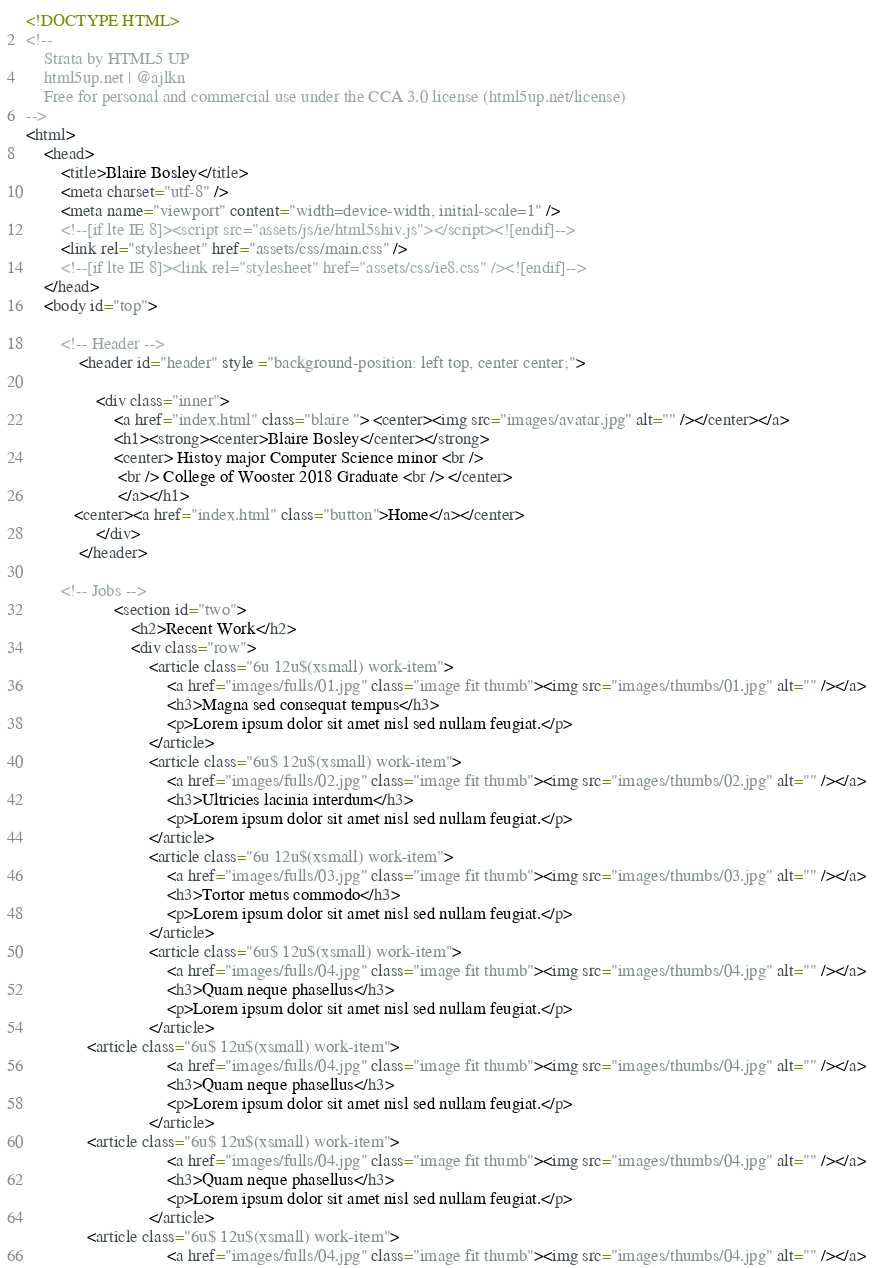<code> <loc_0><loc_0><loc_500><loc_500><_HTML_><!DOCTYPE HTML>
<!--
	Strata by HTML5 UP
	html5up.net | @ajlkn
	Free for personal and commercial use under the CCA 3.0 license (html5up.net/license)
-->
<html>
	<head>
		<title>Blaire Bosley</title>
		<meta charset="utf-8" />
		<meta name="viewport" content="width=device-width, initial-scale=1" />
		<!--[if lte IE 8]><script src="assets/js/ie/html5shiv.js"></script><![endif]-->
		<link rel="stylesheet" href="assets/css/main.css" />
		<!--[if lte IE 8]><link rel="stylesheet" href="assets/css/ie8.css" /><![endif]-->
	</head>
	<body id="top">

		<!-- Header -->
			<header id="header" style ="background-position: left top, center center;">

				<div class="inner">
					<a href="index.html" class="blaire "> <center><img src="images/avatar.jpg" alt="" /></center></a>
					<h1><strong><center>Blaire Bosley</center></strong>
					<center> Histoy major Computer Science minor <br />
					 <br /> College of Wooster 2018 Graduate <br /> </center>
					 </a></h1>
           <center><a href="index.html" class="button">Home</a></center>
				</div>
			</header>

		<!-- Jobs -->
					<section id="two">
						<h2>Recent Work</h2>
						<div class="row">
							<article class="6u 12u$(xsmall) work-item">
								<a href="images/fulls/01.jpg" class="image fit thumb"><img src="images/thumbs/01.jpg" alt="" /></a>
								<h3>Magna sed consequat tempus</h3>
								<p>Lorem ipsum dolor sit amet nisl sed nullam feugiat.</p>
							</article>
							<article class="6u$ 12u$(xsmall) work-item">
								<a href="images/fulls/02.jpg" class="image fit thumb"><img src="images/thumbs/02.jpg" alt="" /></a>
								<h3>Ultricies lacinia interdum</h3>
								<p>Lorem ipsum dolor sit amet nisl sed nullam feugiat.</p>
							</article>
							<article class="6u 12u$(xsmall) work-item">
								<a href="images/fulls/03.jpg" class="image fit thumb"><img src="images/thumbs/03.jpg" alt="" /></a>
								<h3>Tortor metus commodo</h3>
								<p>Lorem ipsum dolor sit amet nisl sed nullam feugiat.</p>
							</article>
							<article class="6u$ 12u$(xsmall) work-item">
								<a href="images/fulls/04.jpg" class="image fit thumb"><img src="images/thumbs/04.jpg" alt="" /></a>
								<h3>Quam neque phasellus</h3>
								<p>Lorem ipsum dolor sit amet nisl sed nullam feugiat.</p>
							</article>
              <article class="6u$ 12u$(xsmall) work-item">
								<a href="images/fulls/04.jpg" class="image fit thumb"><img src="images/thumbs/04.jpg" alt="" /></a>
								<h3>Quam neque phasellus</h3>
								<p>Lorem ipsum dolor sit amet nisl sed nullam feugiat.</p>
							</article>
              <article class="6u$ 12u$(xsmall) work-item">
								<a href="images/fulls/04.jpg" class="image fit thumb"><img src="images/thumbs/04.jpg" alt="" /></a>
								<h3>Quam neque phasellus</h3>
								<p>Lorem ipsum dolor sit amet nisl sed nullam feugiat.</p>
							</article>
              <article class="6u$ 12u$(xsmall) work-item">
								<a href="images/fulls/04.jpg" class="image fit thumb"><img src="images/thumbs/04.jpg" alt="" /></a></code> 